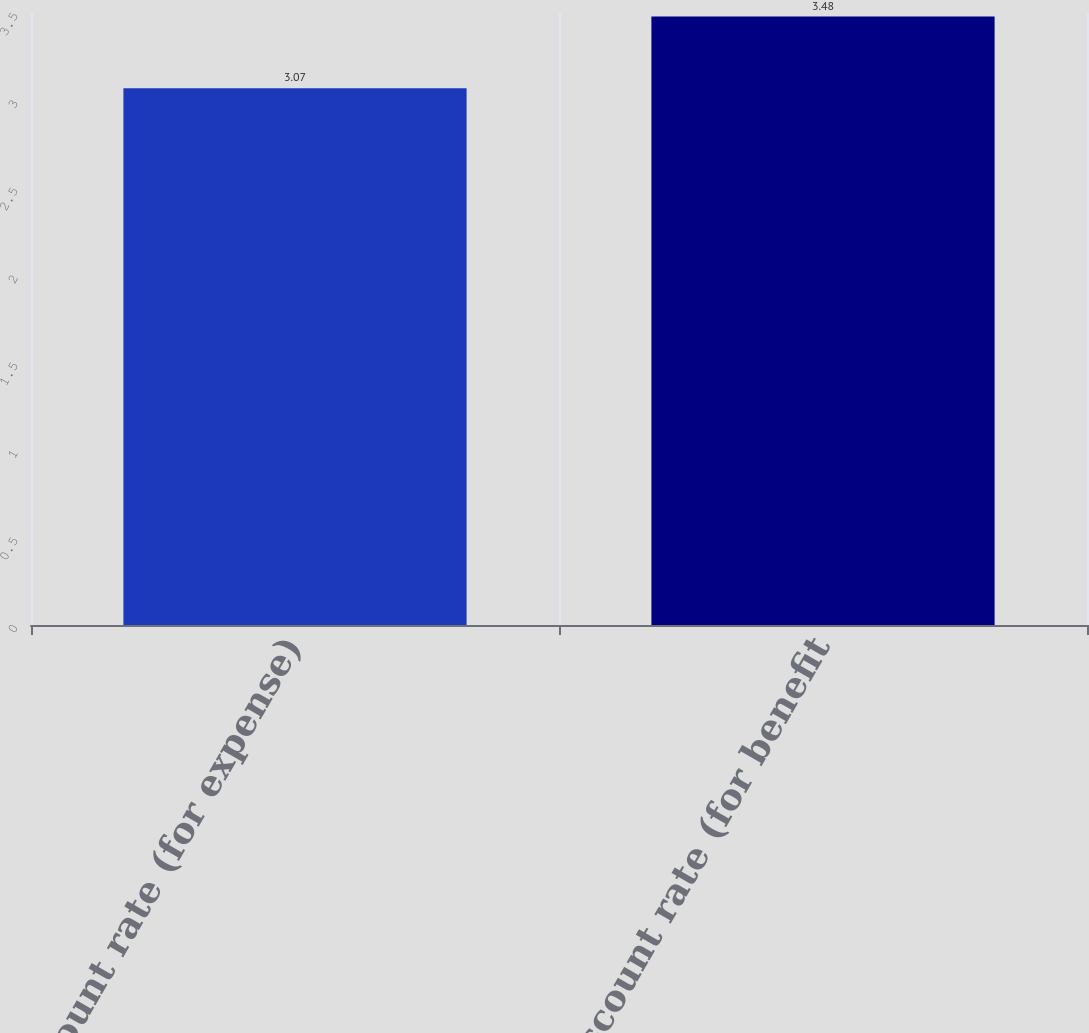Convert chart. <chart><loc_0><loc_0><loc_500><loc_500><bar_chart><fcel>Discount rate (for expense)<fcel>Discount rate (for benefit<nl><fcel>3.07<fcel>3.48<nl></chart> 